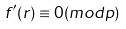Convert formula to latex. <formula><loc_0><loc_0><loc_500><loc_500>f ^ { \prime } ( r ) \equiv 0 ( m o d p )</formula> 